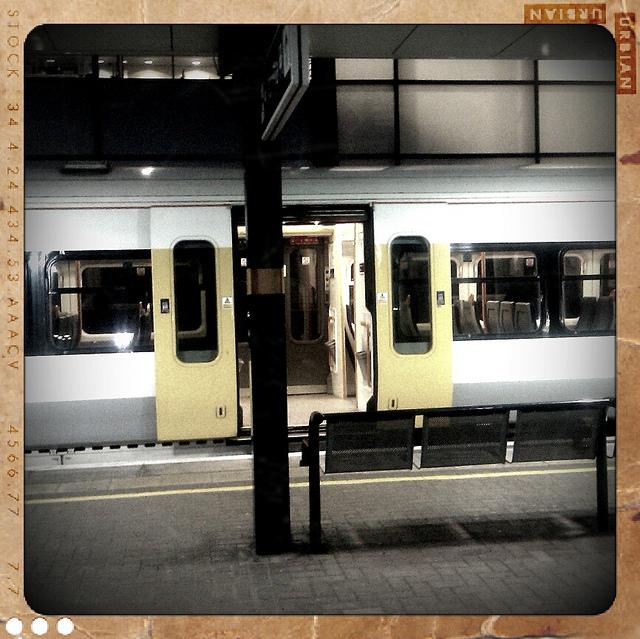Is this a train station in France?
Keep it brief. No. What color are the lines on the train platform?
Short answer required. Yellow. What colors make up the train's doors?
Be succinct. Yellow. Are the subway doors open?
Write a very short answer. Yes. Are there any passengers on the subway?
Keep it brief. No. 